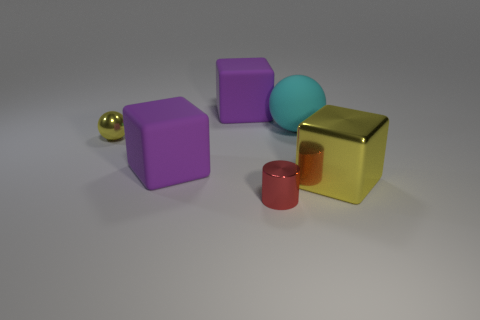Add 1 purple rubber things. How many objects exist? 7 Subtract all cylinders. How many objects are left? 5 Add 2 yellow things. How many yellow things exist? 4 Subtract 0 gray cylinders. How many objects are left? 6 Subtract all yellow shiny balls. Subtract all red cylinders. How many objects are left? 4 Add 4 tiny yellow things. How many tiny yellow things are left? 5 